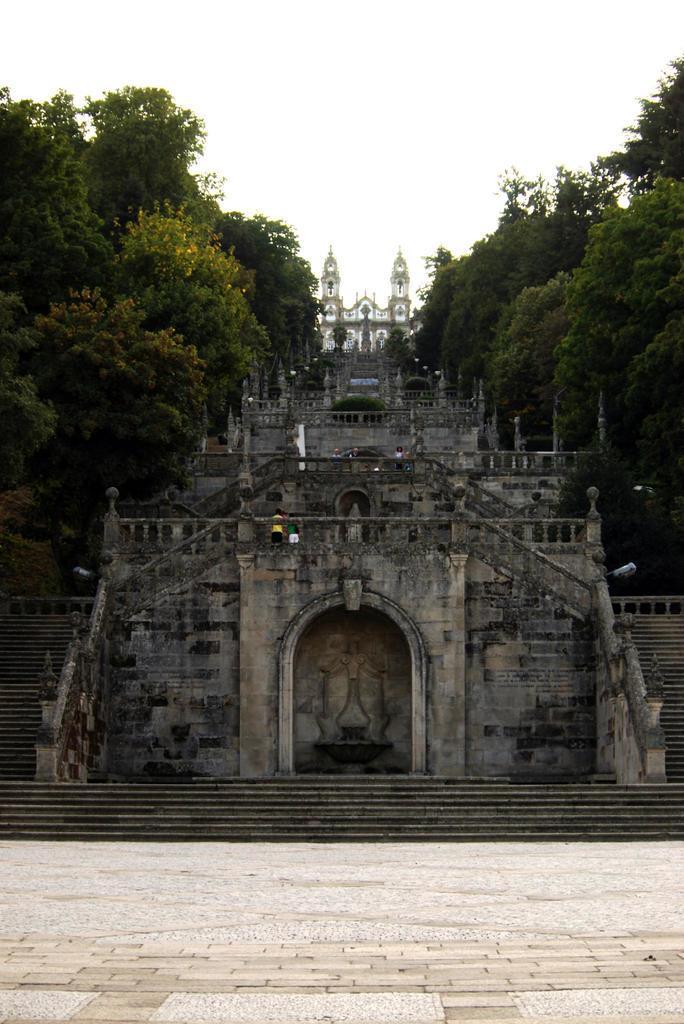Could you give a brief overview of what you see in this image? In front of the image there is some engraving on the monument. In front of the monument there are stairs, besides the monument there are steps with concrete fence, on the fence there are lamps and there are a few people on the monument. Besides the monument there are trees. 